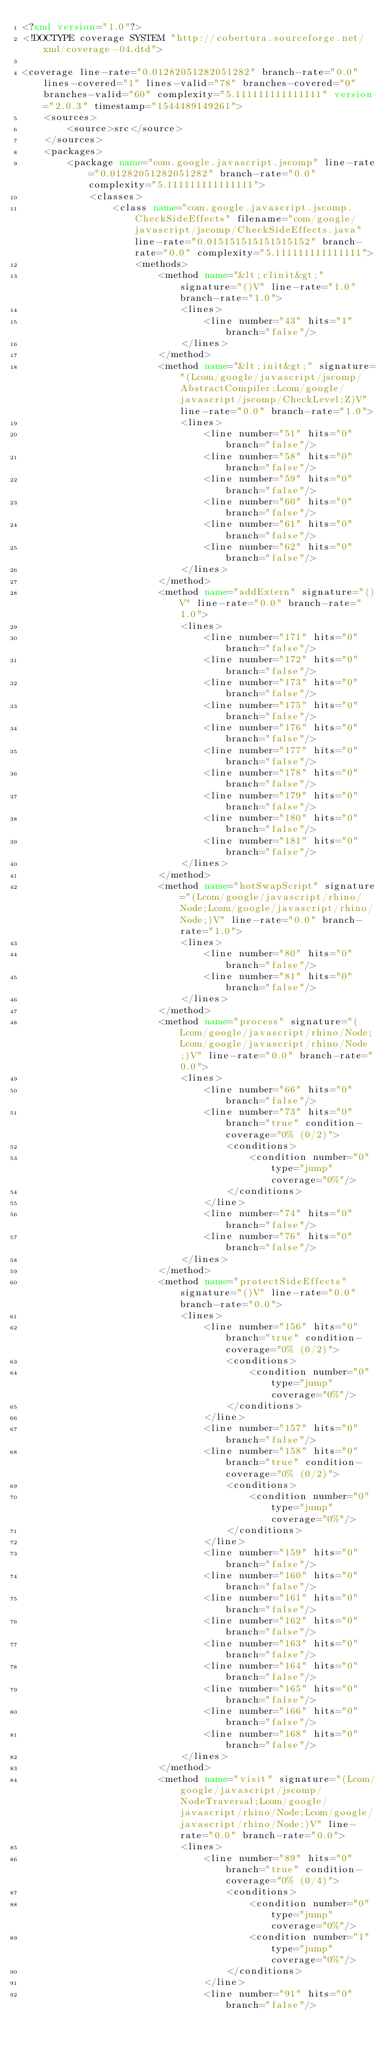<code> <loc_0><loc_0><loc_500><loc_500><_XML_><?xml version="1.0"?>
<!DOCTYPE coverage SYSTEM "http://cobertura.sourceforge.net/xml/coverage-04.dtd">

<coverage line-rate="0.01282051282051282" branch-rate="0.0" lines-covered="1" lines-valid="78" branches-covered="0" branches-valid="60" complexity="5.111111111111111" version="2.0.3" timestamp="1544489149261">
	<sources>
		<source>src</source>
	</sources>
	<packages>
		<package name="com.google.javascript.jscomp" line-rate="0.01282051282051282" branch-rate="0.0" complexity="5.111111111111111">
			<classes>
				<class name="com.google.javascript.jscomp.CheckSideEffects" filename="com/google/javascript/jscomp/CheckSideEffects.java" line-rate="0.015151515151515152" branch-rate="0.0" complexity="5.111111111111111">
					<methods>
						<method name="&lt;clinit&gt;" signature="()V" line-rate="1.0" branch-rate="1.0">
							<lines>
								<line number="43" hits="1" branch="false"/>
							</lines>
						</method>
						<method name="&lt;init&gt;" signature="(Lcom/google/javascript/jscomp/AbstractCompiler;Lcom/google/javascript/jscomp/CheckLevel;Z)V" line-rate="0.0" branch-rate="1.0">
							<lines>
								<line number="51" hits="0" branch="false"/>
								<line number="58" hits="0" branch="false"/>
								<line number="59" hits="0" branch="false"/>
								<line number="60" hits="0" branch="false"/>
								<line number="61" hits="0" branch="false"/>
								<line number="62" hits="0" branch="false"/>
							</lines>
						</method>
						<method name="addExtern" signature="()V" line-rate="0.0" branch-rate="1.0">
							<lines>
								<line number="171" hits="0" branch="false"/>
								<line number="172" hits="0" branch="false"/>
								<line number="173" hits="0" branch="false"/>
								<line number="175" hits="0" branch="false"/>
								<line number="176" hits="0" branch="false"/>
								<line number="177" hits="0" branch="false"/>
								<line number="178" hits="0" branch="false"/>
								<line number="179" hits="0" branch="false"/>
								<line number="180" hits="0" branch="false"/>
								<line number="181" hits="0" branch="false"/>
							</lines>
						</method>
						<method name="hotSwapScript" signature="(Lcom/google/javascript/rhino/Node;Lcom/google/javascript/rhino/Node;)V" line-rate="0.0" branch-rate="1.0">
							<lines>
								<line number="80" hits="0" branch="false"/>
								<line number="81" hits="0" branch="false"/>
							</lines>
						</method>
						<method name="process" signature="(Lcom/google/javascript/rhino/Node;Lcom/google/javascript/rhino/Node;)V" line-rate="0.0" branch-rate="0.0">
							<lines>
								<line number="66" hits="0" branch="false"/>
								<line number="73" hits="0" branch="true" condition-coverage="0% (0/2)">
									<conditions>
										<condition number="0" type="jump" coverage="0%"/>
									</conditions>
								</line>
								<line number="74" hits="0" branch="false"/>
								<line number="76" hits="0" branch="false"/>
							</lines>
						</method>
						<method name="protectSideEffects" signature="()V" line-rate="0.0" branch-rate="0.0">
							<lines>
								<line number="156" hits="0" branch="true" condition-coverage="0% (0/2)">
									<conditions>
										<condition number="0" type="jump" coverage="0%"/>
									</conditions>
								</line>
								<line number="157" hits="0" branch="false"/>
								<line number="158" hits="0" branch="true" condition-coverage="0% (0/2)">
									<conditions>
										<condition number="0" type="jump" coverage="0%"/>
									</conditions>
								</line>
								<line number="159" hits="0" branch="false"/>
								<line number="160" hits="0" branch="false"/>
								<line number="161" hits="0" branch="false"/>
								<line number="162" hits="0" branch="false"/>
								<line number="163" hits="0" branch="false"/>
								<line number="164" hits="0" branch="false"/>
								<line number="165" hits="0" branch="false"/>
								<line number="166" hits="0" branch="false"/>
								<line number="168" hits="0" branch="false"/>
							</lines>
						</method>
						<method name="visit" signature="(Lcom/google/javascript/jscomp/NodeTraversal;Lcom/google/javascript/rhino/Node;Lcom/google/javascript/rhino/Node;)V" line-rate="0.0" branch-rate="0.0">
							<lines>
								<line number="89" hits="0" branch="true" condition-coverage="0% (0/4)">
									<conditions>
										<condition number="0" type="jump" coverage="0%"/>
										<condition number="1" type="jump" coverage="0%"/>
									</conditions>
								</line>
								<line number="91" hits="0" branch="false"/></code> 